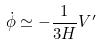Convert formula to latex. <formula><loc_0><loc_0><loc_500><loc_500>\dot { \phi } \simeq - \frac { 1 } { 3 H } V ^ { \prime }</formula> 